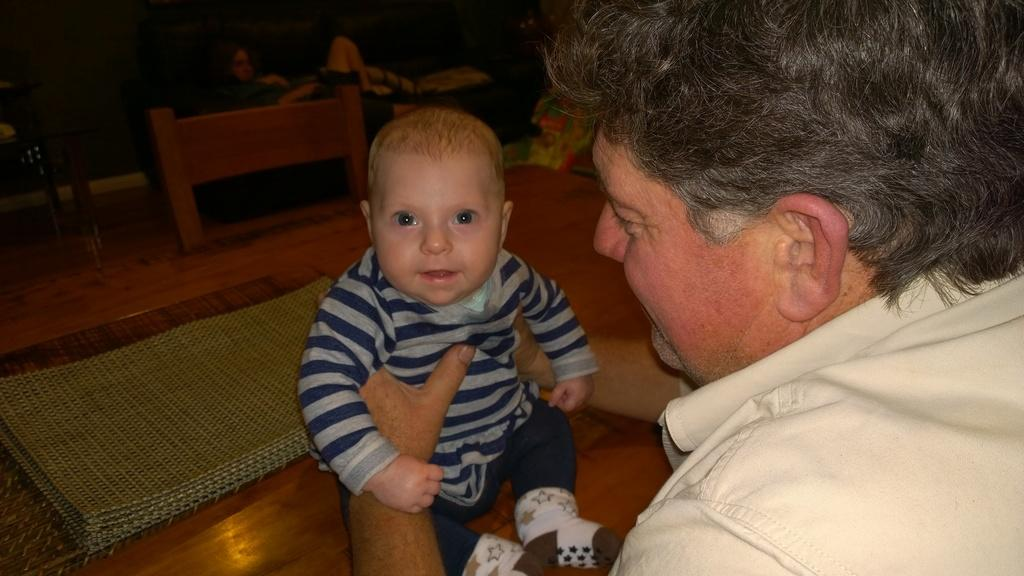Who is in the image? There is a man in the image. What is the man doing in the image? The man is holding a baby in the image. Where is the baby sitting? The baby is sitting on a table in the image. What is on the table? There are mats on the table in the image. What is beside the table? There is a chair beside the table in the image. How does the wind affect the baby's position on the table in the image? There is no wind present in the image, so its effect on the baby's position cannot be determined. What type of plate is being used to serve the baby's food in the image? There is no plate visible in the image; the baby is sitting on mats on the table. 